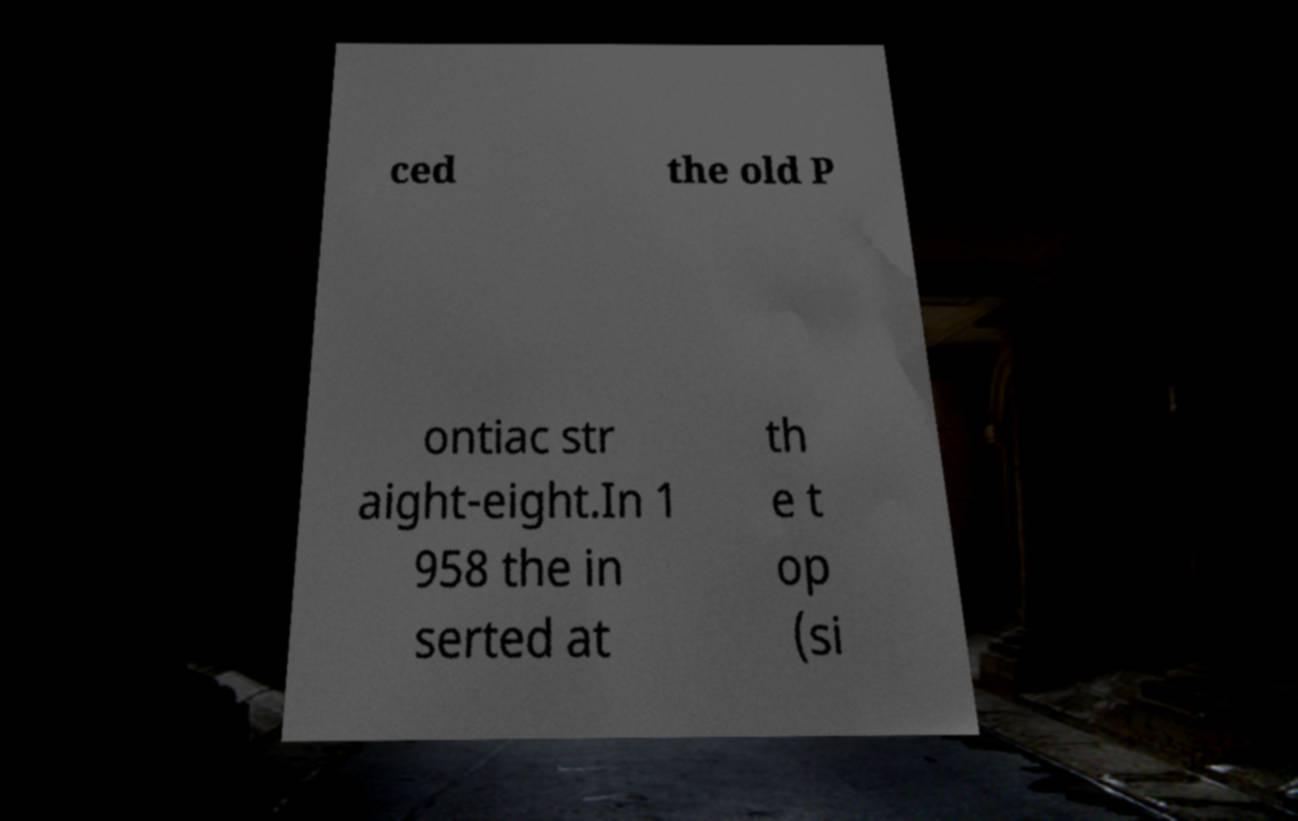There's text embedded in this image that I need extracted. Can you transcribe it verbatim? ced the old P ontiac str aight-eight.In 1 958 the in serted at th e t op (si 